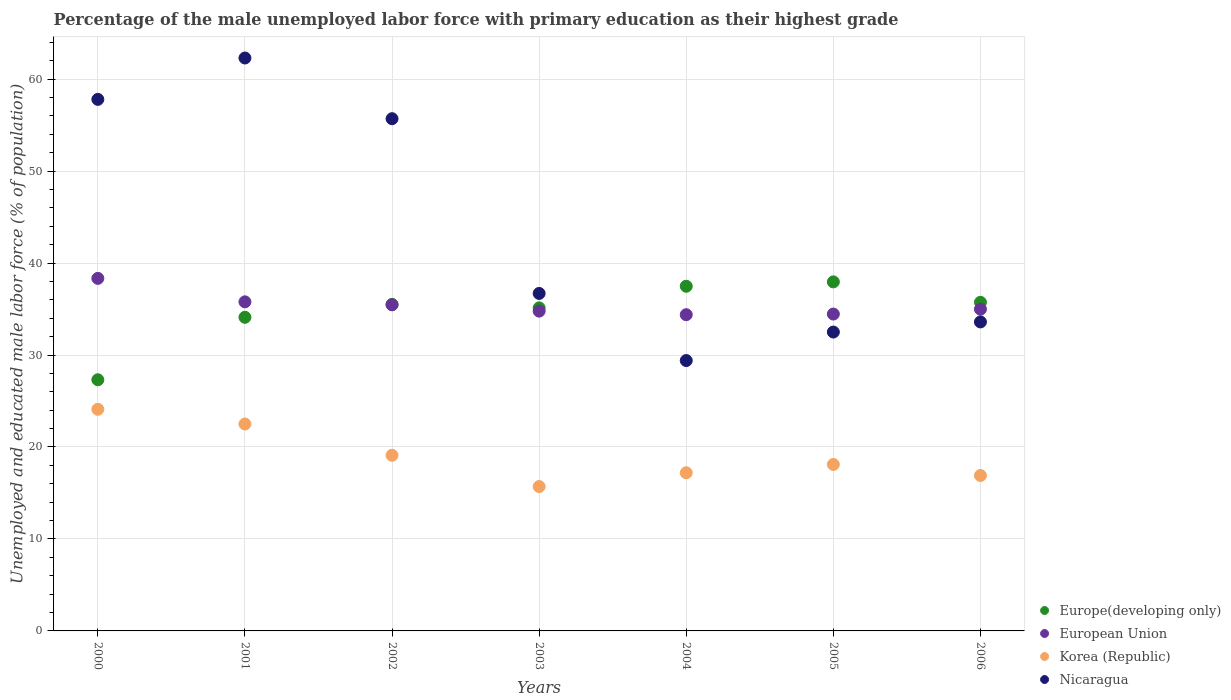How many different coloured dotlines are there?
Your answer should be very brief. 4. What is the percentage of the unemployed male labor force with primary education in Nicaragua in 2001?
Ensure brevity in your answer.  62.3. Across all years, what is the maximum percentage of the unemployed male labor force with primary education in European Union?
Give a very brief answer. 38.34. Across all years, what is the minimum percentage of the unemployed male labor force with primary education in Europe(developing only)?
Offer a very short reply. 27.31. In which year was the percentage of the unemployed male labor force with primary education in European Union maximum?
Ensure brevity in your answer.  2000. What is the total percentage of the unemployed male labor force with primary education in Nicaragua in the graph?
Provide a succinct answer. 308. What is the difference between the percentage of the unemployed male labor force with primary education in European Union in 2003 and that in 2006?
Keep it short and to the point. -0.21. What is the difference between the percentage of the unemployed male labor force with primary education in Nicaragua in 2002 and the percentage of the unemployed male labor force with primary education in Korea (Republic) in 2000?
Your answer should be very brief. 31.6. What is the average percentage of the unemployed male labor force with primary education in Europe(developing only) per year?
Offer a very short reply. 34.75. In the year 2006, what is the difference between the percentage of the unemployed male labor force with primary education in Korea (Republic) and percentage of the unemployed male labor force with primary education in European Union?
Give a very brief answer. -18.09. In how many years, is the percentage of the unemployed male labor force with primary education in Europe(developing only) greater than 36 %?
Keep it short and to the point. 2. What is the ratio of the percentage of the unemployed male labor force with primary education in Korea (Republic) in 2000 to that in 2002?
Your answer should be very brief. 1.26. Is the percentage of the unemployed male labor force with primary education in Nicaragua in 2000 less than that in 2005?
Give a very brief answer. No. Is the difference between the percentage of the unemployed male labor force with primary education in Korea (Republic) in 2001 and 2003 greater than the difference between the percentage of the unemployed male labor force with primary education in European Union in 2001 and 2003?
Your response must be concise. Yes. What is the difference between the highest and the second highest percentage of the unemployed male labor force with primary education in Korea (Republic)?
Provide a short and direct response. 1.6. What is the difference between the highest and the lowest percentage of the unemployed male labor force with primary education in Korea (Republic)?
Ensure brevity in your answer.  8.4. Is the sum of the percentage of the unemployed male labor force with primary education in European Union in 2002 and 2005 greater than the maximum percentage of the unemployed male labor force with primary education in Nicaragua across all years?
Make the answer very short. Yes. Is it the case that in every year, the sum of the percentage of the unemployed male labor force with primary education in Korea (Republic) and percentage of the unemployed male labor force with primary education in Europe(developing only)  is greater than the sum of percentage of the unemployed male labor force with primary education in Nicaragua and percentage of the unemployed male labor force with primary education in European Union?
Keep it short and to the point. No. How many dotlines are there?
Ensure brevity in your answer.  4. Are the values on the major ticks of Y-axis written in scientific E-notation?
Offer a terse response. No. Does the graph contain any zero values?
Make the answer very short. No. Where does the legend appear in the graph?
Your response must be concise. Bottom right. How are the legend labels stacked?
Provide a succinct answer. Vertical. What is the title of the graph?
Your answer should be compact. Percentage of the male unemployed labor force with primary education as their highest grade. Does "Euro area" appear as one of the legend labels in the graph?
Make the answer very short. No. What is the label or title of the X-axis?
Provide a succinct answer. Years. What is the label or title of the Y-axis?
Make the answer very short. Unemployed and educated male labor force (% of population). What is the Unemployed and educated male labor force (% of population) in Europe(developing only) in 2000?
Provide a succinct answer. 27.31. What is the Unemployed and educated male labor force (% of population) of European Union in 2000?
Your answer should be very brief. 38.34. What is the Unemployed and educated male labor force (% of population) in Korea (Republic) in 2000?
Your response must be concise. 24.1. What is the Unemployed and educated male labor force (% of population) of Nicaragua in 2000?
Give a very brief answer. 57.8. What is the Unemployed and educated male labor force (% of population) of Europe(developing only) in 2001?
Your response must be concise. 34.1. What is the Unemployed and educated male labor force (% of population) of European Union in 2001?
Offer a very short reply. 35.79. What is the Unemployed and educated male labor force (% of population) of Korea (Republic) in 2001?
Provide a succinct answer. 22.5. What is the Unemployed and educated male labor force (% of population) of Nicaragua in 2001?
Provide a succinct answer. 62.3. What is the Unemployed and educated male labor force (% of population) in Europe(developing only) in 2002?
Keep it short and to the point. 35.51. What is the Unemployed and educated male labor force (% of population) of European Union in 2002?
Make the answer very short. 35.46. What is the Unemployed and educated male labor force (% of population) in Korea (Republic) in 2002?
Provide a short and direct response. 19.1. What is the Unemployed and educated male labor force (% of population) in Nicaragua in 2002?
Keep it short and to the point. 55.7. What is the Unemployed and educated male labor force (% of population) in Europe(developing only) in 2003?
Make the answer very short. 35.13. What is the Unemployed and educated male labor force (% of population) in European Union in 2003?
Your response must be concise. 34.77. What is the Unemployed and educated male labor force (% of population) in Korea (Republic) in 2003?
Give a very brief answer. 15.7. What is the Unemployed and educated male labor force (% of population) in Nicaragua in 2003?
Give a very brief answer. 36.7. What is the Unemployed and educated male labor force (% of population) in Europe(developing only) in 2004?
Your answer should be compact. 37.48. What is the Unemployed and educated male labor force (% of population) of European Union in 2004?
Make the answer very short. 34.39. What is the Unemployed and educated male labor force (% of population) in Korea (Republic) in 2004?
Your response must be concise. 17.2. What is the Unemployed and educated male labor force (% of population) in Nicaragua in 2004?
Keep it short and to the point. 29.4. What is the Unemployed and educated male labor force (% of population) of Europe(developing only) in 2005?
Your response must be concise. 37.96. What is the Unemployed and educated male labor force (% of population) of European Union in 2005?
Your answer should be very brief. 34.46. What is the Unemployed and educated male labor force (% of population) in Korea (Republic) in 2005?
Your response must be concise. 18.1. What is the Unemployed and educated male labor force (% of population) of Nicaragua in 2005?
Offer a very short reply. 32.5. What is the Unemployed and educated male labor force (% of population) in Europe(developing only) in 2006?
Offer a terse response. 35.73. What is the Unemployed and educated male labor force (% of population) of European Union in 2006?
Ensure brevity in your answer.  34.99. What is the Unemployed and educated male labor force (% of population) of Korea (Republic) in 2006?
Provide a short and direct response. 16.9. What is the Unemployed and educated male labor force (% of population) of Nicaragua in 2006?
Make the answer very short. 33.6. Across all years, what is the maximum Unemployed and educated male labor force (% of population) in Europe(developing only)?
Offer a terse response. 37.96. Across all years, what is the maximum Unemployed and educated male labor force (% of population) in European Union?
Make the answer very short. 38.34. Across all years, what is the maximum Unemployed and educated male labor force (% of population) in Korea (Republic)?
Give a very brief answer. 24.1. Across all years, what is the maximum Unemployed and educated male labor force (% of population) of Nicaragua?
Your answer should be compact. 62.3. Across all years, what is the minimum Unemployed and educated male labor force (% of population) of Europe(developing only)?
Ensure brevity in your answer.  27.31. Across all years, what is the minimum Unemployed and educated male labor force (% of population) of European Union?
Keep it short and to the point. 34.39. Across all years, what is the minimum Unemployed and educated male labor force (% of population) of Korea (Republic)?
Ensure brevity in your answer.  15.7. Across all years, what is the minimum Unemployed and educated male labor force (% of population) in Nicaragua?
Make the answer very short. 29.4. What is the total Unemployed and educated male labor force (% of population) in Europe(developing only) in the graph?
Provide a succinct answer. 243.22. What is the total Unemployed and educated male labor force (% of population) of European Union in the graph?
Offer a very short reply. 248.19. What is the total Unemployed and educated male labor force (% of population) in Korea (Republic) in the graph?
Provide a short and direct response. 133.6. What is the total Unemployed and educated male labor force (% of population) of Nicaragua in the graph?
Offer a terse response. 308. What is the difference between the Unemployed and educated male labor force (% of population) in Europe(developing only) in 2000 and that in 2001?
Your answer should be very brief. -6.79. What is the difference between the Unemployed and educated male labor force (% of population) of European Union in 2000 and that in 2001?
Your answer should be compact. 2.55. What is the difference between the Unemployed and educated male labor force (% of population) in Europe(developing only) in 2000 and that in 2002?
Your response must be concise. -8.2. What is the difference between the Unemployed and educated male labor force (% of population) in European Union in 2000 and that in 2002?
Your answer should be compact. 2.88. What is the difference between the Unemployed and educated male labor force (% of population) of Nicaragua in 2000 and that in 2002?
Offer a very short reply. 2.1. What is the difference between the Unemployed and educated male labor force (% of population) of Europe(developing only) in 2000 and that in 2003?
Your response must be concise. -7.82. What is the difference between the Unemployed and educated male labor force (% of population) of European Union in 2000 and that in 2003?
Keep it short and to the point. 3.56. What is the difference between the Unemployed and educated male labor force (% of population) of Korea (Republic) in 2000 and that in 2003?
Your answer should be compact. 8.4. What is the difference between the Unemployed and educated male labor force (% of population) of Nicaragua in 2000 and that in 2003?
Your answer should be very brief. 21.1. What is the difference between the Unemployed and educated male labor force (% of population) of Europe(developing only) in 2000 and that in 2004?
Offer a very short reply. -10.17. What is the difference between the Unemployed and educated male labor force (% of population) in European Union in 2000 and that in 2004?
Offer a terse response. 3.95. What is the difference between the Unemployed and educated male labor force (% of population) of Korea (Republic) in 2000 and that in 2004?
Provide a succinct answer. 6.9. What is the difference between the Unemployed and educated male labor force (% of population) of Nicaragua in 2000 and that in 2004?
Your answer should be compact. 28.4. What is the difference between the Unemployed and educated male labor force (% of population) of Europe(developing only) in 2000 and that in 2005?
Your answer should be very brief. -10.64. What is the difference between the Unemployed and educated male labor force (% of population) of European Union in 2000 and that in 2005?
Ensure brevity in your answer.  3.88. What is the difference between the Unemployed and educated male labor force (% of population) of Nicaragua in 2000 and that in 2005?
Keep it short and to the point. 25.3. What is the difference between the Unemployed and educated male labor force (% of population) of Europe(developing only) in 2000 and that in 2006?
Your answer should be compact. -8.42. What is the difference between the Unemployed and educated male labor force (% of population) in European Union in 2000 and that in 2006?
Keep it short and to the point. 3.35. What is the difference between the Unemployed and educated male labor force (% of population) of Korea (Republic) in 2000 and that in 2006?
Give a very brief answer. 7.2. What is the difference between the Unemployed and educated male labor force (% of population) in Nicaragua in 2000 and that in 2006?
Your answer should be compact. 24.2. What is the difference between the Unemployed and educated male labor force (% of population) in Europe(developing only) in 2001 and that in 2002?
Provide a succinct answer. -1.41. What is the difference between the Unemployed and educated male labor force (% of population) of European Union in 2001 and that in 2002?
Keep it short and to the point. 0.32. What is the difference between the Unemployed and educated male labor force (% of population) of Europe(developing only) in 2001 and that in 2003?
Provide a short and direct response. -1.03. What is the difference between the Unemployed and educated male labor force (% of population) in European Union in 2001 and that in 2003?
Make the answer very short. 1.01. What is the difference between the Unemployed and educated male labor force (% of population) of Korea (Republic) in 2001 and that in 2003?
Your answer should be very brief. 6.8. What is the difference between the Unemployed and educated male labor force (% of population) in Nicaragua in 2001 and that in 2003?
Offer a terse response. 25.6. What is the difference between the Unemployed and educated male labor force (% of population) of Europe(developing only) in 2001 and that in 2004?
Offer a terse response. -3.38. What is the difference between the Unemployed and educated male labor force (% of population) in European Union in 2001 and that in 2004?
Your answer should be very brief. 1.4. What is the difference between the Unemployed and educated male labor force (% of population) in Nicaragua in 2001 and that in 2004?
Ensure brevity in your answer.  32.9. What is the difference between the Unemployed and educated male labor force (% of population) in Europe(developing only) in 2001 and that in 2005?
Ensure brevity in your answer.  -3.85. What is the difference between the Unemployed and educated male labor force (% of population) of European Union in 2001 and that in 2005?
Provide a succinct answer. 1.33. What is the difference between the Unemployed and educated male labor force (% of population) in Korea (Republic) in 2001 and that in 2005?
Your response must be concise. 4.4. What is the difference between the Unemployed and educated male labor force (% of population) in Nicaragua in 2001 and that in 2005?
Your response must be concise. 29.8. What is the difference between the Unemployed and educated male labor force (% of population) of Europe(developing only) in 2001 and that in 2006?
Make the answer very short. -1.63. What is the difference between the Unemployed and educated male labor force (% of population) of European Union in 2001 and that in 2006?
Your answer should be very brief. 0.8. What is the difference between the Unemployed and educated male labor force (% of population) of Korea (Republic) in 2001 and that in 2006?
Give a very brief answer. 5.6. What is the difference between the Unemployed and educated male labor force (% of population) of Nicaragua in 2001 and that in 2006?
Give a very brief answer. 28.7. What is the difference between the Unemployed and educated male labor force (% of population) of Europe(developing only) in 2002 and that in 2003?
Offer a very short reply. 0.38. What is the difference between the Unemployed and educated male labor force (% of population) in European Union in 2002 and that in 2003?
Ensure brevity in your answer.  0.69. What is the difference between the Unemployed and educated male labor force (% of population) in Korea (Republic) in 2002 and that in 2003?
Make the answer very short. 3.4. What is the difference between the Unemployed and educated male labor force (% of population) in Nicaragua in 2002 and that in 2003?
Make the answer very short. 19. What is the difference between the Unemployed and educated male labor force (% of population) in Europe(developing only) in 2002 and that in 2004?
Make the answer very short. -1.97. What is the difference between the Unemployed and educated male labor force (% of population) of European Union in 2002 and that in 2004?
Make the answer very short. 1.08. What is the difference between the Unemployed and educated male labor force (% of population) of Nicaragua in 2002 and that in 2004?
Ensure brevity in your answer.  26.3. What is the difference between the Unemployed and educated male labor force (% of population) of Europe(developing only) in 2002 and that in 2005?
Make the answer very short. -2.45. What is the difference between the Unemployed and educated male labor force (% of population) in European Union in 2002 and that in 2005?
Your answer should be compact. 1.01. What is the difference between the Unemployed and educated male labor force (% of population) of Nicaragua in 2002 and that in 2005?
Offer a terse response. 23.2. What is the difference between the Unemployed and educated male labor force (% of population) of Europe(developing only) in 2002 and that in 2006?
Ensure brevity in your answer.  -0.22. What is the difference between the Unemployed and educated male labor force (% of population) of European Union in 2002 and that in 2006?
Provide a succinct answer. 0.48. What is the difference between the Unemployed and educated male labor force (% of population) of Nicaragua in 2002 and that in 2006?
Offer a terse response. 22.1. What is the difference between the Unemployed and educated male labor force (% of population) of Europe(developing only) in 2003 and that in 2004?
Provide a short and direct response. -2.35. What is the difference between the Unemployed and educated male labor force (% of population) of European Union in 2003 and that in 2004?
Your answer should be compact. 0.39. What is the difference between the Unemployed and educated male labor force (% of population) in Europe(developing only) in 2003 and that in 2005?
Offer a terse response. -2.83. What is the difference between the Unemployed and educated male labor force (% of population) of European Union in 2003 and that in 2005?
Offer a terse response. 0.32. What is the difference between the Unemployed and educated male labor force (% of population) of Korea (Republic) in 2003 and that in 2005?
Provide a short and direct response. -2.4. What is the difference between the Unemployed and educated male labor force (% of population) of Europe(developing only) in 2003 and that in 2006?
Your response must be concise. -0.6. What is the difference between the Unemployed and educated male labor force (% of population) of European Union in 2003 and that in 2006?
Ensure brevity in your answer.  -0.21. What is the difference between the Unemployed and educated male labor force (% of population) in Korea (Republic) in 2003 and that in 2006?
Make the answer very short. -1.2. What is the difference between the Unemployed and educated male labor force (% of population) in Europe(developing only) in 2004 and that in 2005?
Offer a terse response. -0.47. What is the difference between the Unemployed and educated male labor force (% of population) in European Union in 2004 and that in 2005?
Your answer should be compact. -0.07. What is the difference between the Unemployed and educated male labor force (% of population) of Korea (Republic) in 2004 and that in 2005?
Give a very brief answer. -0.9. What is the difference between the Unemployed and educated male labor force (% of population) in Europe(developing only) in 2004 and that in 2006?
Offer a very short reply. 1.75. What is the difference between the Unemployed and educated male labor force (% of population) in European Union in 2004 and that in 2006?
Provide a succinct answer. -0.6. What is the difference between the Unemployed and educated male labor force (% of population) of Korea (Republic) in 2004 and that in 2006?
Your response must be concise. 0.3. What is the difference between the Unemployed and educated male labor force (% of population) of Nicaragua in 2004 and that in 2006?
Your response must be concise. -4.2. What is the difference between the Unemployed and educated male labor force (% of population) in Europe(developing only) in 2005 and that in 2006?
Keep it short and to the point. 2.22. What is the difference between the Unemployed and educated male labor force (% of population) of European Union in 2005 and that in 2006?
Make the answer very short. -0.53. What is the difference between the Unemployed and educated male labor force (% of population) of Europe(developing only) in 2000 and the Unemployed and educated male labor force (% of population) of European Union in 2001?
Your answer should be very brief. -8.48. What is the difference between the Unemployed and educated male labor force (% of population) in Europe(developing only) in 2000 and the Unemployed and educated male labor force (% of population) in Korea (Republic) in 2001?
Provide a succinct answer. 4.81. What is the difference between the Unemployed and educated male labor force (% of population) of Europe(developing only) in 2000 and the Unemployed and educated male labor force (% of population) of Nicaragua in 2001?
Offer a terse response. -34.99. What is the difference between the Unemployed and educated male labor force (% of population) in European Union in 2000 and the Unemployed and educated male labor force (% of population) in Korea (Republic) in 2001?
Make the answer very short. 15.84. What is the difference between the Unemployed and educated male labor force (% of population) in European Union in 2000 and the Unemployed and educated male labor force (% of population) in Nicaragua in 2001?
Give a very brief answer. -23.96. What is the difference between the Unemployed and educated male labor force (% of population) in Korea (Republic) in 2000 and the Unemployed and educated male labor force (% of population) in Nicaragua in 2001?
Provide a short and direct response. -38.2. What is the difference between the Unemployed and educated male labor force (% of population) of Europe(developing only) in 2000 and the Unemployed and educated male labor force (% of population) of European Union in 2002?
Offer a terse response. -8.15. What is the difference between the Unemployed and educated male labor force (% of population) in Europe(developing only) in 2000 and the Unemployed and educated male labor force (% of population) in Korea (Republic) in 2002?
Keep it short and to the point. 8.21. What is the difference between the Unemployed and educated male labor force (% of population) of Europe(developing only) in 2000 and the Unemployed and educated male labor force (% of population) of Nicaragua in 2002?
Keep it short and to the point. -28.39. What is the difference between the Unemployed and educated male labor force (% of population) of European Union in 2000 and the Unemployed and educated male labor force (% of population) of Korea (Republic) in 2002?
Make the answer very short. 19.24. What is the difference between the Unemployed and educated male labor force (% of population) of European Union in 2000 and the Unemployed and educated male labor force (% of population) of Nicaragua in 2002?
Your answer should be compact. -17.36. What is the difference between the Unemployed and educated male labor force (% of population) of Korea (Republic) in 2000 and the Unemployed and educated male labor force (% of population) of Nicaragua in 2002?
Make the answer very short. -31.6. What is the difference between the Unemployed and educated male labor force (% of population) of Europe(developing only) in 2000 and the Unemployed and educated male labor force (% of population) of European Union in 2003?
Your response must be concise. -7.46. What is the difference between the Unemployed and educated male labor force (% of population) in Europe(developing only) in 2000 and the Unemployed and educated male labor force (% of population) in Korea (Republic) in 2003?
Your answer should be very brief. 11.61. What is the difference between the Unemployed and educated male labor force (% of population) in Europe(developing only) in 2000 and the Unemployed and educated male labor force (% of population) in Nicaragua in 2003?
Provide a succinct answer. -9.39. What is the difference between the Unemployed and educated male labor force (% of population) in European Union in 2000 and the Unemployed and educated male labor force (% of population) in Korea (Republic) in 2003?
Offer a terse response. 22.64. What is the difference between the Unemployed and educated male labor force (% of population) in European Union in 2000 and the Unemployed and educated male labor force (% of population) in Nicaragua in 2003?
Your answer should be compact. 1.64. What is the difference between the Unemployed and educated male labor force (% of population) of Korea (Republic) in 2000 and the Unemployed and educated male labor force (% of population) of Nicaragua in 2003?
Offer a very short reply. -12.6. What is the difference between the Unemployed and educated male labor force (% of population) of Europe(developing only) in 2000 and the Unemployed and educated male labor force (% of population) of European Union in 2004?
Offer a terse response. -7.07. What is the difference between the Unemployed and educated male labor force (% of population) of Europe(developing only) in 2000 and the Unemployed and educated male labor force (% of population) of Korea (Republic) in 2004?
Make the answer very short. 10.11. What is the difference between the Unemployed and educated male labor force (% of population) of Europe(developing only) in 2000 and the Unemployed and educated male labor force (% of population) of Nicaragua in 2004?
Your answer should be very brief. -2.09. What is the difference between the Unemployed and educated male labor force (% of population) in European Union in 2000 and the Unemployed and educated male labor force (% of population) in Korea (Republic) in 2004?
Ensure brevity in your answer.  21.14. What is the difference between the Unemployed and educated male labor force (% of population) in European Union in 2000 and the Unemployed and educated male labor force (% of population) in Nicaragua in 2004?
Make the answer very short. 8.94. What is the difference between the Unemployed and educated male labor force (% of population) in Korea (Republic) in 2000 and the Unemployed and educated male labor force (% of population) in Nicaragua in 2004?
Provide a succinct answer. -5.3. What is the difference between the Unemployed and educated male labor force (% of population) in Europe(developing only) in 2000 and the Unemployed and educated male labor force (% of population) in European Union in 2005?
Your answer should be compact. -7.15. What is the difference between the Unemployed and educated male labor force (% of population) in Europe(developing only) in 2000 and the Unemployed and educated male labor force (% of population) in Korea (Republic) in 2005?
Offer a very short reply. 9.21. What is the difference between the Unemployed and educated male labor force (% of population) of Europe(developing only) in 2000 and the Unemployed and educated male labor force (% of population) of Nicaragua in 2005?
Give a very brief answer. -5.19. What is the difference between the Unemployed and educated male labor force (% of population) in European Union in 2000 and the Unemployed and educated male labor force (% of population) in Korea (Republic) in 2005?
Your answer should be compact. 20.24. What is the difference between the Unemployed and educated male labor force (% of population) in European Union in 2000 and the Unemployed and educated male labor force (% of population) in Nicaragua in 2005?
Your answer should be very brief. 5.84. What is the difference between the Unemployed and educated male labor force (% of population) of Korea (Republic) in 2000 and the Unemployed and educated male labor force (% of population) of Nicaragua in 2005?
Make the answer very short. -8.4. What is the difference between the Unemployed and educated male labor force (% of population) in Europe(developing only) in 2000 and the Unemployed and educated male labor force (% of population) in European Union in 2006?
Keep it short and to the point. -7.68. What is the difference between the Unemployed and educated male labor force (% of population) in Europe(developing only) in 2000 and the Unemployed and educated male labor force (% of population) in Korea (Republic) in 2006?
Your answer should be compact. 10.41. What is the difference between the Unemployed and educated male labor force (% of population) of Europe(developing only) in 2000 and the Unemployed and educated male labor force (% of population) of Nicaragua in 2006?
Your response must be concise. -6.29. What is the difference between the Unemployed and educated male labor force (% of population) in European Union in 2000 and the Unemployed and educated male labor force (% of population) in Korea (Republic) in 2006?
Give a very brief answer. 21.44. What is the difference between the Unemployed and educated male labor force (% of population) of European Union in 2000 and the Unemployed and educated male labor force (% of population) of Nicaragua in 2006?
Make the answer very short. 4.74. What is the difference between the Unemployed and educated male labor force (% of population) in Europe(developing only) in 2001 and the Unemployed and educated male labor force (% of population) in European Union in 2002?
Give a very brief answer. -1.36. What is the difference between the Unemployed and educated male labor force (% of population) in Europe(developing only) in 2001 and the Unemployed and educated male labor force (% of population) in Korea (Republic) in 2002?
Offer a very short reply. 15. What is the difference between the Unemployed and educated male labor force (% of population) in Europe(developing only) in 2001 and the Unemployed and educated male labor force (% of population) in Nicaragua in 2002?
Provide a short and direct response. -21.6. What is the difference between the Unemployed and educated male labor force (% of population) of European Union in 2001 and the Unemployed and educated male labor force (% of population) of Korea (Republic) in 2002?
Your response must be concise. 16.69. What is the difference between the Unemployed and educated male labor force (% of population) of European Union in 2001 and the Unemployed and educated male labor force (% of population) of Nicaragua in 2002?
Provide a succinct answer. -19.91. What is the difference between the Unemployed and educated male labor force (% of population) of Korea (Republic) in 2001 and the Unemployed and educated male labor force (% of population) of Nicaragua in 2002?
Ensure brevity in your answer.  -33.2. What is the difference between the Unemployed and educated male labor force (% of population) of Europe(developing only) in 2001 and the Unemployed and educated male labor force (% of population) of European Union in 2003?
Your answer should be very brief. -0.67. What is the difference between the Unemployed and educated male labor force (% of population) in Europe(developing only) in 2001 and the Unemployed and educated male labor force (% of population) in Korea (Republic) in 2003?
Provide a short and direct response. 18.4. What is the difference between the Unemployed and educated male labor force (% of population) in Europe(developing only) in 2001 and the Unemployed and educated male labor force (% of population) in Nicaragua in 2003?
Keep it short and to the point. -2.6. What is the difference between the Unemployed and educated male labor force (% of population) of European Union in 2001 and the Unemployed and educated male labor force (% of population) of Korea (Republic) in 2003?
Give a very brief answer. 20.09. What is the difference between the Unemployed and educated male labor force (% of population) of European Union in 2001 and the Unemployed and educated male labor force (% of population) of Nicaragua in 2003?
Your answer should be very brief. -0.91. What is the difference between the Unemployed and educated male labor force (% of population) in Korea (Republic) in 2001 and the Unemployed and educated male labor force (% of population) in Nicaragua in 2003?
Your response must be concise. -14.2. What is the difference between the Unemployed and educated male labor force (% of population) in Europe(developing only) in 2001 and the Unemployed and educated male labor force (% of population) in European Union in 2004?
Your response must be concise. -0.28. What is the difference between the Unemployed and educated male labor force (% of population) in Europe(developing only) in 2001 and the Unemployed and educated male labor force (% of population) in Korea (Republic) in 2004?
Provide a succinct answer. 16.9. What is the difference between the Unemployed and educated male labor force (% of population) in Europe(developing only) in 2001 and the Unemployed and educated male labor force (% of population) in Nicaragua in 2004?
Make the answer very short. 4.7. What is the difference between the Unemployed and educated male labor force (% of population) of European Union in 2001 and the Unemployed and educated male labor force (% of population) of Korea (Republic) in 2004?
Keep it short and to the point. 18.59. What is the difference between the Unemployed and educated male labor force (% of population) in European Union in 2001 and the Unemployed and educated male labor force (% of population) in Nicaragua in 2004?
Your response must be concise. 6.39. What is the difference between the Unemployed and educated male labor force (% of population) in Korea (Republic) in 2001 and the Unemployed and educated male labor force (% of population) in Nicaragua in 2004?
Keep it short and to the point. -6.9. What is the difference between the Unemployed and educated male labor force (% of population) in Europe(developing only) in 2001 and the Unemployed and educated male labor force (% of population) in European Union in 2005?
Ensure brevity in your answer.  -0.35. What is the difference between the Unemployed and educated male labor force (% of population) of Europe(developing only) in 2001 and the Unemployed and educated male labor force (% of population) of Korea (Republic) in 2005?
Offer a terse response. 16. What is the difference between the Unemployed and educated male labor force (% of population) of Europe(developing only) in 2001 and the Unemployed and educated male labor force (% of population) of Nicaragua in 2005?
Provide a short and direct response. 1.6. What is the difference between the Unemployed and educated male labor force (% of population) of European Union in 2001 and the Unemployed and educated male labor force (% of population) of Korea (Republic) in 2005?
Keep it short and to the point. 17.69. What is the difference between the Unemployed and educated male labor force (% of population) of European Union in 2001 and the Unemployed and educated male labor force (% of population) of Nicaragua in 2005?
Your response must be concise. 3.29. What is the difference between the Unemployed and educated male labor force (% of population) in Korea (Republic) in 2001 and the Unemployed and educated male labor force (% of population) in Nicaragua in 2005?
Provide a short and direct response. -10. What is the difference between the Unemployed and educated male labor force (% of population) in Europe(developing only) in 2001 and the Unemployed and educated male labor force (% of population) in European Union in 2006?
Offer a very short reply. -0.88. What is the difference between the Unemployed and educated male labor force (% of population) of Europe(developing only) in 2001 and the Unemployed and educated male labor force (% of population) of Korea (Republic) in 2006?
Your answer should be compact. 17.2. What is the difference between the Unemployed and educated male labor force (% of population) of Europe(developing only) in 2001 and the Unemployed and educated male labor force (% of population) of Nicaragua in 2006?
Make the answer very short. 0.5. What is the difference between the Unemployed and educated male labor force (% of population) in European Union in 2001 and the Unemployed and educated male labor force (% of population) in Korea (Republic) in 2006?
Offer a very short reply. 18.89. What is the difference between the Unemployed and educated male labor force (% of population) in European Union in 2001 and the Unemployed and educated male labor force (% of population) in Nicaragua in 2006?
Provide a succinct answer. 2.19. What is the difference between the Unemployed and educated male labor force (% of population) in Europe(developing only) in 2002 and the Unemployed and educated male labor force (% of population) in European Union in 2003?
Offer a terse response. 0.73. What is the difference between the Unemployed and educated male labor force (% of population) in Europe(developing only) in 2002 and the Unemployed and educated male labor force (% of population) in Korea (Republic) in 2003?
Provide a short and direct response. 19.81. What is the difference between the Unemployed and educated male labor force (% of population) in Europe(developing only) in 2002 and the Unemployed and educated male labor force (% of population) in Nicaragua in 2003?
Offer a very short reply. -1.19. What is the difference between the Unemployed and educated male labor force (% of population) in European Union in 2002 and the Unemployed and educated male labor force (% of population) in Korea (Republic) in 2003?
Offer a very short reply. 19.76. What is the difference between the Unemployed and educated male labor force (% of population) in European Union in 2002 and the Unemployed and educated male labor force (% of population) in Nicaragua in 2003?
Provide a succinct answer. -1.24. What is the difference between the Unemployed and educated male labor force (% of population) of Korea (Republic) in 2002 and the Unemployed and educated male labor force (% of population) of Nicaragua in 2003?
Provide a succinct answer. -17.6. What is the difference between the Unemployed and educated male labor force (% of population) of Europe(developing only) in 2002 and the Unemployed and educated male labor force (% of population) of European Union in 2004?
Make the answer very short. 1.12. What is the difference between the Unemployed and educated male labor force (% of population) in Europe(developing only) in 2002 and the Unemployed and educated male labor force (% of population) in Korea (Republic) in 2004?
Offer a terse response. 18.31. What is the difference between the Unemployed and educated male labor force (% of population) in Europe(developing only) in 2002 and the Unemployed and educated male labor force (% of population) in Nicaragua in 2004?
Keep it short and to the point. 6.11. What is the difference between the Unemployed and educated male labor force (% of population) in European Union in 2002 and the Unemployed and educated male labor force (% of population) in Korea (Republic) in 2004?
Keep it short and to the point. 18.26. What is the difference between the Unemployed and educated male labor force (% of population) in European Union in 2002 and the Unemployed and educated male labor force (% of population) in Nicaragua in 2004?
Provide a short and direct response. 6.06. What is the difference between the Unemployed and educated male labor force (% of population) of Korea (Republic) in 2002 and the Unemployed and educated male labor force (% of population) of Nicaragua in 2004?
Give a very brief answer. -10.3. What is the difference between the Unemployed and educated male labor force (% of population) of Europe(developing only) in 2002 and the Unemployed and educated male labor force (% of population) of European Union in 2005?
Offer a very short reply. 1.05. What is the difference between the Unemployed and educated male labor force (% of population) in Europe(developing only) in 2002 and the Unemployed and educated male labor force (% of population) in Korea (Republic) in 2005?
Give a very brief answer. 17.41. What is the difference between the Unemployed and educated male labor force (% of population) in Europe(developing only) in 2002 and the Unemployed and educated male labor force (% of population) in Nicaragua in 2005?
Your answer should be very brief. 3.01. What is the difference between the Unemployed and educated male labor force (% of population) of European Union in 2002 and the Unemployed and educated male labor force (% of population) of Korea (Republic) in 2005?
Provide a short and direct response. 17.36. What is the difference between the Unemployed and educated male labor force (% of population) of European Union in 2002 and the Unemployed and educated male labor force (% of population) of Nicaragua in 2005?
Ensure brevity in your answer.  2.96. What is the difference between the Unemployed and educated male labor force (% of population) in Korea (Republic) in 2002 and the Unemployed and educated male labor force (% of population) in Nicaragua in 2005?
Ensure brevity in your answer.  -13.4. What is the difference between the Unemployed and educated male labor force (% of population) in Europe(developing only) in 2002 and the Unemployed and educated male labor force (% of population) in European Union in 2006?
Your answer should be compact. 0.52. What is the difference between the Unemployed and educated male labor force (% of population) of Europe(developing only) in 2002 and the Unemployed and educated male labor force (% of population) of Korea (Republic) in 2006?
Your answer should be compact. 18.61. What is the difference between the Unemployed and educated male labor force (% of population) in Europe(developing only) in 2002 and the Unemployed and educated male labor force (% of population) in Nicaragua in 2006?
Your answer should be very brief. 1.91. What is the difference between the Unemployed and educated male labor force (% of population) of European Union in 2002 and the Unemployed and educated male labor force (% of population) of Korea (Republic) in 2006?
Provide a succinct answer. 18.56. What is the difference between the Unemployed and educated male labor force (% of population) in European Union in 2002 and the Unemployed and educated male labor force (% of population) in Nicaragua in 2006?
Offer a very short reply. 1.86. What is the difference between the Unemployed and educated male labor force (% of population) in Europe(developing only) in 2003 and the Unemployed and educated male labor force (% of population) in European Union in 2004?
Provide a succinct answer. 0.74. What is the difference between the Unemployed and educated male labor force (% of population) in Europe(developing only) in 2003 and the Unemployed and educated male labor force (% of population) in Korea (Republic) in 2004?
Ensure brevity in your answer.  17.93. What is the difference between the Unemployed and educated male labor force (% of population) in Europe(developing only) in 2003 and the Unemployed and educated male labor force (% of population) in Nicaragua in 2004?
Your response must be concise. 5.73. What is the difference between the Unemployed and educated male labor force (% of population) in European Union in 2003 and the Unemployed and educated male labor force (% of population) in Korea (Republic) in 2004?
Keep it short and to the point. 17.57. What is the difference between the Unemployed and educated male labor force (% of population) in European Union in 2003 and the Unemployed and educated male labor force (% of population) in Nicaragua in 2004?
Your answer should be very brief. 5.37. What is the difference between the Unemployed and educated male labor force (% of population) of Korea (Republic) in 2003 and the Unemployed and educated male labor force (% of population) of Nicaragua in 2004?
Your response must be concise. -13.7. What is the difference between the Unemployed and educated male labor force (% of population) in Europe(developing only) in 2003 and the Unemployed and educated male labor force (% of population) in European Union in 2005?
Your answer should be very brief. 0.67. What is the difference between the Unemployed and educated male labor force (% of population) in Europe(developing only) in 2003 and the Unemployed and educated male labor force (% of population) in Korea (Republic) in 2005?
Keep it short and to the point. 17.03. What is the difference between the Unemployed and educated male labor force (% of population) of Europe(developing only) in 2003 and the Unemployed and educated male labor force (% of population) of Nicaragua in 2005?
Offer a terse response. 2.63. What is the difference between the Unemployed and educated male labor force (% of population) of European Union in 2003 and the Unemployed and educated male labor force (% of population) of Korea (Republic) in 2005?
Offer a very short reply. 16.67. What is the difference between the Unemployed and educated male labor force (% of population) of European Union in 2003 and the Unemployed and educated male labor force (% of population) of Nicaragua in 2005?
Offer a terse response. 2.27. What is the difference between the Unemployed and educated male labor force (% of population) of Korea (Republic) in 2003 and the Unemployed and educated male labor force (% of population) of Nicaragua in 2005?
Ensure brevity in your answer.  -16.8. What is the difference between the Unemployed and educated male labor force (% of population) of Europe(developing only) in 2003 and the Unemployed and educated male labor force (% of population) of European Union in 2006?
Make the answer very short. 0.14. What is the difference between the Unemployed and educated male labor force (% of population) in Europe(developing only) in 2003 and the Unemployed and educated male labor force (% of population) in Korea (Republic) in 2006?
Your response must be concise. 18.23. What is the difference between the Unemployed and educated male labor force (% of population) in Europe(developing only) in 2003 and the Unemployed and educated male labor force (% of population) in Nicaragua in 2006?
Offer a very short reply. 1.53. What is the difference between the Unemployed and educated male labor force (% of population) in European Union in 2003 and the Unemployed and educated male labor force (% of population) in Korea (Republic) in 2006?
Give a very brief answer. 17.87. What is the difference between the Unemployed and educated male labor force (% of population) in European Union in 2003 and the Unemployed and educated male labor force (% of population) in Nicaragua in 2006?
Give a very brief answer. 1.17. What is the difference between the Unemployed and educated male labor force (% of population) of Korea (Republic) in 2003 and the Unemployed and educated male labor force (% of population) of Nicaragua in 2006?
Provide a succinct answer. -17.9. What is the difference between the Unemployed and educated male labor force (% of population) in Europe(developing only) in 2004 and the Unemployed and educated male labor force (% of population) in European Union in 2005?
Keep it short and to the point. 3.02. What is the difference between the Unemployed and educated male labor force (% of population) in Europe(developing only) in 2004 and the Unemployed and educated male labor force (% of population) in Korea (Republic) in 2005?
Offer a terse response. 19.38. What is the difference between the Unemployed and educated male labor force (% of population) in Europe(developing only) in 2004 and the Unemployed and educated male labor force (% of population) in Nicaragua in 2005?
Keep it short and to the point. 4.98. What is the difference between the Unemployed and educated male labor force (% of population) in European Union in 2004 and the Unemployed and educated male labor force (% of population) in Korea (Republic) in 2005?
Give a very brief answer. 16.29. What is the difference between the Unemployed and educated male labor force (% of population) in European Union in 2004 and the Unemployed and educated male labor force (% of population) in Nicaragua in 2005?
Keep it short and to the point. 1.89. What is the difference between the Unemployed and educated male labor force (% of population) of Korea (Republic) in 2004 and the Unemployed and educated male labor force (% of population) of Nicaragua in 2005?
Your answer should be very brief. -15.3. What is the difference between the Unemployed and educated male labor force (% of population) in Europe(developing only) in 2004 and the Unemployed and educated male labor force (% of population) in European Union in 2006?
Offer a terse response. 2.49. What is the difference between the Unemployed and educated male labor force (% of population) in Europe(developing only) in 2004 and the Unemployed and educated male labor force (% of population) in Korea (Republic) in 2006?
Your answer should be very brief. 20.58. What is the difference between the Unemployed and educated male labor force (% of population) of Europe(developing only) in 2004 and the Unemployed and educated male labor force (% of population) of Nicaragua in 2006?
Provide a short and direct response. 3.88. What is the difference between the Unemployed and educated male labor force (% of population) of European Union in 2004 and the Unemployed and educated male labor force (% of population) of Korea (Republic) in 2006?
Keep it short and to the point. 17.49. What is the difference between the Unemployed and educated male labor force (% of population) of European Union in 2004 and the Unemployed and educated male labor force (% of population) of Nicaragua in 2006?
Give a very brief answer. 0.79. What is the difference between the Unemployed and educated male labor force (% of population) in Korea (Republic) in 2004 and the Unemployed and educated male labor force (% of population) in Nicaragua in 2006?
Ensure brevity in your answer.  -16.4. What is the difference between the Unemployed and educated male labor force (% of population) of Europe(developing only) in 2005 and the Unemployed and educated male labor force (% of population) of European Union in 2006?
Your answer should be compact. 2.97. What is the difference between the Unemployed and educated male labor force (% of population) in Europe(developing only) in 2005 and the Unemployed and educated male labor force (% of population) in Korea (Republic) in 2006?
Your answer should be compact. 21.06. What is the difference between the Unemployed and educated male labor force (% of population) in Europe(developing only) in 2005 and the Unemployed and educated male labor force (% of population) in Nicaragua in 2006?
Give a very brief answer. 4.36. What is the difference between the Unemployed and educated male labor force (% of population) of European Union in 2005 and the Unemployed and educated male labor force (% of population) of Korea (Republic) in 2006?
Provide a succinct answer. 17.56. What is the difference between the Unemployed and educated male labor force (% of population) in European Union in 2005 and the Unemployed and educated male labor force (% of population) in Nicaragua in 2006?
Give a very brief answer. 0.86. What is the difference between the Unemployed and educated male labor force (% of population) in Korea (Republic) in 2005 and the Unemployed and educated male labor force (% of population) in Nicaragua in 2006?
Your response must be concise. -15.5. What is the average Unemployed and educated male labor force (% of population) of Europe(developing only) per year?
Give a very brief answer. 34.75. What is the average Unemployed and educated male labor force (% of population) of European Union per year?
Provide a succinct answer. 35.46. What is the average Unemployed and educated male labor force (% of population) in Korea (Republic) per year?
Offer a very short reply. 19.09. In the year 2000, what is the difference between the Unemployed and educated male labor force (% of population) of Europe(developing only) and Unemployed and educated male labor force (% of population) of European Union?
Your answer should be compact. -11.03. In the year 2000, what is the difference between the Unemployed and educated male labor force (% of population) in Europe(developing only) and Unemployed and educated male labor force (% of population) in Korea (Republic)?
Your response must be concise. 3.21. In the year 2000, what is the difference between the Unemployed and educated male labor force (% of population) in Europe(developing only) and Unemployed and educated male labor force (% of population) in Nicaragua?
Your answer should be very brief. -30.49. In the year 2000, what is the difference between the Unemployed and educated male labor force (% of population) of European Union and Unemployed and educated male labor force (% of population) of Korea (Republic)?
Keep it short and to the point. 14.24. In the year 2000, what is the difference between the Unemployed and educated male labor force (% of population) of European Union and Unemployed and educated male labor force (% of population) of Nicaragua?
Offer a very short reply. -19.46. In the year 2000, what is the difference between the Unemployed and educated male labor force (% of population) in Korea (Republic) and Unemployed and educated male labor force (% of population) in Nicaragua?
Offer a terse response. -33.7. In the year 2001, what is the difference between the Unemployed and educated male labor force (% of population) of Europe(developing only) and Unemployed and educated male labor force (% of population) of European Union?
Your answer should be very brief. -1.68. In the year 2001, what is the difference between the Unemployed and educated male labor force (% of population) in Europe(developing only) and Unemployed and educated male labor force (% of population) in Korea (Republic)?
Offer a very short reply. 11.6. In the year 2001, what is the difference between the Unemployed and educated male labor force (% of population) of Europe(developing only) and Unemployed and educated male labor force (% of population) of Nicaragua?
Offer a terse response. -28.2. In the year 2001, what is the difference between the Unemployed and educated male labor force (% of population) of European Union and Unemployed and educated male labor force (% of population) of Korea (Republic)?
Provide a short and direct response. 13.29. In the year 2001, what is the difference between the Unemployed and educated male labor force (% of population) of European Union and Unemployed and educated male labor force (% of population) of Nicaragua?
Keep it short and to the point. -26.51. In the year 2001, what is the difference between the Unemployed and educated male labor force (% of population) in Korea (Republic) and Unemployed and educated male labor force (% of population) in Nicaragua?
Keep it short and to the point. -39.8. In the year 2002, what is the difference between the Unemployed and educated male labor force (% of population) in Europe(developing only) and Unemployed and educated male labor force (% of population) in European Union?
Your answer should be very brief. 0.05. In the year 2002, what is the difference between the Unemployed and educated male labor force (% of population) of Europe(developing only) and Unemployed and educated male labor force (% of population) of Korea (Republic)?
Keep it short and to the point. 16.41. In the year 2002, what is the difference between the Unemployed and educated male labor force (% of population) of Europe(developing only) and Unemployed and educated male labor force (% of population) of Nicaragua?
Offer a very short reply. -20.19. In the year 2002, what is the difference between the Unemployed and educated male labor force (% of population) of European Union and Unemployed and educated male labor force (% of population) of Korea (Republic)?
Provide a succinct answer. 16.36. In the year 2002, what is the difference between the Unemployed and educated male labor force (% of population) of European Union and Unemployed and educated male labor force (% of population) of Nicaragua?
Give a very brief answer. -20.24. In the year 2002, what is the difference between the Unemployed and educated male labor force (% of population) of Korea (Republic) and Unemployed and educated male labor force (% of population) of Nicaragua?
Offer a very short reply. -36.6. In the year 2003, what is the difference between the Unemployed and educated male labor force (% of population) in Europe(developing only) and Unemployed and educated male labor force (% of population) in European Union?
Provide a short and direct response. 0.36. In the year 2003, what is the difference between the Unemployed and educated male labor force (% of population) of Europe(developing only) and Unemployed and educated male labor force (% of population) of Korea (Republic)?
Offer a terse response. 19.43. In the year 2003, what is the difference between the Unemployed and educated male labor force (% of population) in Europe(developing only) and Unemployed and educated male labor force (% of population) in Nicaragua?
Offer a very short reply. -1.57. In the year 2003, what is the difference between the Unemployed and educated male labor force (% of population) in European Union and Unemployed and educated male labor force (% of population) in Korea (Republic)?
Offer a terse response. 19.07. In the year 2003, what is the difference between the Unemployed and educated male labor force (% of population) of European Union and Unemployed and educated male labor force (% of population) of Nicaragua?
Give a very brief answer. -1.93. In the year 2004, what is the difference between the Unemployed and educated male labor force (% of population) of Europe(developing only) and Unemployed and educated male labor force (% of population) of European Union?
Your answer should be very brief. 3.1. In the year 2004, what is the difference between the Unemployed and educated male labor force (% of population) of Europe(developing only) and Unemployed and educated male labor force (% of population) of Korea (Republic)?
Offer a terse response. 20.28. In the year 2004, what is the difference between the Unemployed and educated male labor force (% of population) in Europe(developing only) and Unemployed and educated male labor force (% of population) in Nicaragua?
Offer a very short reply. 8.08. In the year 2004, what is the difference between the Unemployed and educated male labor force (% of population) of European Union and Unemployed and educated male labor force (% of population) of Korea (Republic)?
Offer a terse response. 17.19. In the year 2004, what is the difference between the Unemployed and educated male labor force (% of population) of European Union and Unemployed and educated male labor force (% of population) of Nicaragua?
Offer a terse response. 4.99. In the year 2005, what is the difference between the Unemployed and educated male labor force (% of population) in Europe(developing only) and Unemployed and educated male labor force (% of population) in European Union?
Your response must be concise. 3.5. In the year 2005, what is the difference between the Unemployed and educated male labor force (% of population) of Europe(developing only) and Unemployed and educated male labor force (% of population) of Korea (Republic)?
Provide a short and direct response. 19.86. In the year 2005, what is the difference between the Unemployed and educated male labor force (% of population) of Europe(developing only) and Unemployed and educated male labor force (% of population) of Nicaragua?
Your response must be concise. 5.46. In the year 2005, what is the difference between the Unemployed and educated male labor force (% of population) in European Union and Unemployed and educated male labor force (% of population) in Korea (Republic)?
Provide a succinct answer. 16.36. In the year 2005, what is the difference between the Unemployed and educated male labor force (% of population) of European Union and Unemployed and educated male labor force (% of population) of Nicaragua?
Provide a short and direct response. 1.96. In the year 2005, what is the difference between the Unemployed and educated male labor force (% of population) of Korea (Republic) and Unemployed and educated male labor force (% of population) of Nicaragua?
Your response must be concise. -14.4. In the year 2006, what is the difference between the Unemployed and educated male labor force (% of population) in Europe(developing only) and Unemployed and educated male labor force (% of population) in European Union?
Your answer should be very brief. 0.75. In the year 2006, what is the difference between the Unemployed and educated male labor force (% of population) of Europe(developing only) and Unemployed and educated male labor force (% of population) of Korea (Republic)?
Your response must be concise. 18.83. In the year 2006, what is the difference between the Unemployed and educated male labor force (% of population) of Europe(developing only) and Unemployed and educated male labor force (% of population) of Nicaragua?
Offer a terse response. 2.13. In the year 2006, what is the difference between the Unemployed and educated male labor force (% of population) of European Union and Unemployed and educated male labor force (% of population) of Korea (Republic)?
Ensure brevity in your answer.  18.09. In the year 2006, what is the difference between the Unemployed and educated male labor force (% of population) of European Union and Unemployed and educated male labor force (% of population) of Nicaragua?
Offer a terse response. 1.39. In the year 2006, what is the difference between the Unemployed and educated male labor force (% of population) of Korea (Republic) and Unemployed and educated male labor force (% of population) of Nicaragua?
Keep it short and to the point. -16.7. What is the ratio of the Unemployed and educated male labor force (% of population) of Europe(developing only) in 2000 to that in 2001?
Provide a succinct answer. 0.8. What is the ratio of the Unemployed and educated male labor force (% of population) in European Union in 2000 to that in 2001?
Your answer should be compact. 1.07. What is the ratio of the Unemployed and educated male labor force (% of population) in Korea (Republic) in 2000 to that in 2001?
Ensure brevity in your answer.  1.07. What is the ratio of the Unemployed and educated male labor force (% of population) in Nicaragua in 2000 to that in 2001?
Your answer should be compact. 0.93. What is the ratio of the Unemployed and educated male labor force (% of population) in Europe(developing only) in 2000 to that in 2002?
Ensure brevity in your answer.  0.77. What is the ratio of the Unemployed and educated male labor force (% of population) of European Union in 2000 to that in 2002?
Make the answer very short. 1.08. What is the ratio of the Unemployed and educated male labor force (% of population) of Korea (Republic) in 2000 to that in 2002?
Offer a very short reply. 1.26. What is the ratio of the Unemployed and educated male labor force (% of population) of Nicaragua in 2000 to that in 2002?
Your response must be concise. 1.04. What is the ratio of the Unemployed and educated male labor force (% of population) of Europe(developing only) in 2000 to that in 2003?
Your answer should be very brief. 0.78. What is the ratio of the Unemployed and educated male labor force (% of population) in European Union in 2000 to that in 2003?
Make the answer very short. 1.1. What is the ratio of the Unemployed and educated male labor force (% of population) of Korea (Republic) in 2000 to that in 2003?
Provide a succinct answer. 1.53. What is the ratio of the Unemployed and educated male labor force (% of population) of Nicaragua in 2000 to that in 2003?
Provide a short and direct response. 1.57. What is the ratio of the Unemployed and educated male labor force (% of population) of Europe(developing only) in 2000 to that in 2004?
Your answer should be very brief. 0.73. What is the ratio of the Unemployed and educated male labor force (% of population) in European Union in 2000 to that in 2004?
Ensure brevity in your answer.  1.11. What is the ratio of the Unemployed and educated male labor force (% of population) in Korea (Republic) in 2000 to that in 2004?
Offer a very short reply. 1.4. What is the ratio of the Unemployed and educated male labor force (% of population) in Nicaragua in 2000 to that in 2004?
Your answer should be very brief. 1.97. What is the ratio of the Unemployed and educated male labor force (% of population) of Europe(developing only) in 2000 to that in 2005?
Offer a terse response. 0.72. What is the ratio of the Unemployed and educated male labor force (% of population) of European Union in 2000 to that in 2005?
Offer a very short reply. 1.11. What is the ratio of the Unemployed and educated male labor force (% of population) in Korea (Republic) in 2000 to that in 2005?
Offer a very short reply. 1.33. What is the ratio of the Unemployed and educated male labor force (% of population) of Nicaragua in 2000 to that in 2005?
Offer a terse response. 1.78. What is the ratio of the Unemployed and educated male labor force (% of population) in Europe(developing only) in 2000 to that in 2006?
Keep it short and to the point. 0.76. What is the ratio of the Unemployed and educated male labor force (% of population) in European Union in 2000 to that in 2006?
Offer a very short reply. 1.1. What is the ratio of the Unemployed and educated male labor force (% of population) of Korea (Republic) in 2000 to that in 2006?
Ensure brevity in your answer.  1.43. What is the ratio of the Unemployed and educated male labor force (% of population) in Nicaragua in 2000 to that in 2006?
Make the answer very short. 1.72. What is the ratio of the Unemployed and educated male labor force (% of population) of Europe(developing only) in 2001 to that in 2002?
Make the answer very short. 0.96. What is the ratio of the Unemployed and educated male labor force (% of population) of European Union in 2001 to that in 2002?
Offer a terse response. 1.01. What is the ratio of the Unemployed and educated male labor force (% of population) in Korea (Republic) in 2001 to that in 2002?
Your answer should be compact. 1.18. What is the ratio of the Unemployed and educated male labor force (% of population) in Nicaragua in 2001 to that in 2002?
Provide a succinct answer. 1.12. What is the ratio of the Unemployed and educated male labor force (% of population) of Europe(developing only) in 2001 to that in 2003?
Keep it short and to the point. 0.97. What is the ratio of the Unemployed and educated male labor force (% of population) of European Union in 2001 to that in 2003?
Offer a terse response. 1.03. What is the ratio of the Unemployed and educated male labor force (% of population) in Korea (Republic) in 2001 to that in 2003?
Provide a succinct answer. 1.43. What is the ratio of the Unemployed and educated male labor force (% of population) of Nicaragua in 2001 to that in 2003?
Your answer should be very brief. 1.7. What is the ratio of the Unemployed and educated male labor force (% of population) in Europe(developing only) in 2001 to that in 2004?
Provide a succinct answer. 0.91. What is the ratio of the Unemployed and educated male labor force (% of population) in European Union in 2001 to that in 2004?
Keep it short and to the point. 1.04. What is the ratio of the Unemployed and educated male labor force (% of population) of Korea (Republic) in 2001 to that in 2004?
Your answer should be compact. 1.31. What is the ratio of the Unemployed and educated male labor force (% of population) in Nicaragua in 2001 to that in 2004?
Keep it short and to the point. 2.12. What is the ratio of the Unemployed and educated male labor force (% of population) of Europe(developing only) in 2001 to that in 2005?
Ensure brevity in your answer.  0.9. What is the ratio of the Unemployed and educated male labor force (% of population) in European Union in 2001 to that in 2005?
Give a very brief answer. 1.04. What is the ratio of the Unemployed and educated male labor force (% of population) of Korea (Republic) in 2001 to that in 2005?
Ensure brevity in your answer.  1.24. What is the ratio of the Unemployed and educated male labor force (% of population) of Nicaragua in 2001 to that in 2005?
Offer a terse response. 1.92. What is the ratio of the Unemployed and educated male labor force (% of population) in Europe(developing only) in 2001 to that in 2006?
Your response must be concise. 0.95. What is the ratio of the Unemployed and educated male labor force (% of population) in European Union in 2001 to that in 2006?
Give a very brief answer. 1.02. What is the ratio of the Unemployed and educated male labor force (% of population) in Korea (Republic) in 2001 to that in 2006?
Provide a short and direct response. 1.33. What is the ratio of the Unemployed and educated male labor force (% of population) in Nicaragua in 2001 to that in 2006?
Your answer should be very brief. 1.85. What is the ratio of the Unemployed and educated male labor force (% of population) of Europe(developing only) in 2002 to that in 2003?
Make the answer very short. 1.01. What is the ratio of the Unemployed and educated male labor force (% of population) in European Union in 2002 to that in 2003?
Provide a succinct answer. 1.02. What is the ratio of the Unemployed and educated male labor force (% of population) in Korea (Republic) in 2002 to that in 2003?
Provide a short and direct response. 1.22. What is the ratio of the Unemployed and educated male labor force (% of population) in Nicaragua in 2002 to that in 2003?
Keep it short and to the point. 1.52. What is the ratio of the Unemployed and educated male labor force (% of population) of Europe(developing only) in 2002 to that in 2004?
Give a very brief answer. 0.95. What is the ratio of the Unemployed and educated male labor force (% of population) in European Union in 2002 to that in 2004?
Give a very brief answer. 1.03. What is the ratio of the Unemployed and educated male labor force (% of population) in Korea (Republic) in 2002 to that in 2004?
Your answer should be very brief. 1.11. What is the ratio of the Unemployed and educated male labor force (% of population) of Nicaragua in 2002 to that in 2004?
Your answer should be very brief. 1.89. What is the ratio of the Unemployed and educated male labor force (% of population) in Europe(developing only) in 2002 to that in 2005?
Make the answer very short. 0.94. What is the ratio of the Unemployed and educated male labor force (% of population) in European Union in 2002 to that in 2005?
Provide a short and direct response. 1.03. What is the ratio of the Unemployed and educated male labor force (% of population) in Korea (Republic) in 2002 to that in 2005?
Offer a very short reply. 1.06. What is the ratio of the Unemployed and educated male labor force (% of population) in Nicaragua in 2002 to that in 2005?
Offer a very short reply. 1.71. What is the ratio of the Unemployed and educated male labor force (% of population) of European Union in 2002 to that in 2006?
Ensure brevity in your answer.  1.01. What is the ratio of the Unemployed and educated male labor force (% of population) in Korea (Republic) in 2002 to that in 2006?
Offer a terse response. 1.13. What is the ratio of the Unemployed and educated male labor force (% of population) in Nicaragua in 2002 to that in 2006?
Keep it short and to the point. 1.66. What is the ratio of the Unemployed and educated male labor force (% of population) of Europe(developing only) in 2003 to that in 2004?
Your answer should be very brief. 0.94. What is the ratio of the Unemployed and educated male labor force (% of population) in European Union in 2003 to that in 2004?
Your answer should be very brief. 1.01. What is the ratio of the Unemployed and educated male labor force (% of population) in Korea (Republic) in 2003 to that in 2004?
Offer a terse response. 0.91. What is the ratio of the Unemployed and educated male labor force (% of population) of Nicaragua in 2003 to that in 2004?
Your answer should be very brief. 1.25. What is the ratio of the Unemployed and educated male labor force (% of population) of Europe(developing only) in 2003 to that in 2005?
Your response must be concise. 0.93. What is the ratio of the Unemployed and educated male labor force (% of population) of European Union in 2003 to that in 2005?
Ensure brevity in your answer.  1.01. What is the ratio of the Unemployed and educated male labor force (% of population) in Korea (Republic) in 2003 to that in 2005?
Your answer should be compact. 0.87. What is the ratio of the Unemployed and educated male labor force (% of population) of Nicaragua in 2003 to that in 2005?
Your answer should be compact. 1.13. What is the ratio of the Unemployed and educated male labor force (% of population) in Europe(developing only) in 2003 to that in 2006?
Provide a short and direct response. 0.98. What is the ratio of the Unemployed and educated male labor force (% of population) of Korea (Republic) in 2003 to that in 2006?
Offer a very short reply. 0.93. What is the ratio of the Unemployed and educated male labor force (% of population) of Nicaragua in 2003 to that in 2006?
Your response must be concise. 1.09. What is the ratio of the Unemployed and educated male labor force (% of population) of Europe(developing only) in 2004 to that in 2005?
Give a very brief answer. 0.99. What is the ratio of the Unemployed and educated male labor force (% of population) of European Union in 2004 to that in 2005?
Your response must be concise. 1. What is the ratio of the Unemployed and educated male labor force (% of population) in Korea (Republic) in 2004 to that in 2005?
Keep it short and to the point. 0.95. What is the ratio of the Unemployed and educated male labor force (% of population) in Nicaragua in 2004 to that in 2005?
Give a very brief answer. 0.9. What is the ratio of the Unemployed and educated male labor force (% of population) in Europe(developing only) in 2004 to that in 2006?
Make the answer very short. 1.05. What is the ratio of the Unemployed and educated male labor force (% of population) of European Union in 2004 to that in 2006?
Keep it short and to the point. 0.98. What is the ratio of the Unemployed and educated male labor force (% of population) of Korea (Republic) in 2004 to that in 2006?
Your answer should be very brief. 1.02. What is the ratio of the Unemployed and educated male labor force (% of population) of Europe(developing only) in 2005 to that in 2006?
Give a very brief answer. 1.06. What is the ratio of the Unemployed and educated male labor force (% of population) in European Union in 2005 to that in 2006?
Give a very brief answer. 0.98. What is the ratio of the Unemployed and educated male labor force (% of population) of Korea (Republic) in 2005 to that in 2006?
Offer a terse response. 1.07. What is the ratio of the Unemployed and educated male labor force (% of population) in Nicaragua in 2005 to that in 2006?
Your answer should be very brief. 0.97. What is the difference between the highest and the second highest Unemployed and educated male labor force (% of population) of Europe(developing only)?
Offer a terse response. 0.47. What is the difference between the highest and the second highest Unemployed and educated male labor force (% of population) in European Union?
Ensure brevity in your answer.  2.55. What is the difference between the highest and the second highest Unemployed and educated male labor force (% of population) of Korea (Republic)?
Offer a terse response. 1.6. What is the difference between the highest and the second highest Unemployed and educated male labor force (% of population) of Nicaragua?
Offer a very short reply. 4.5. What is the difference between the highest and the lowest Unemployed and educated male labor force (% of population) in Europe(developing only)?
Make the answer very short. 10.64. What is the difference between the highest and the lowest Unemployed and educated male labor force (% of population) in European Union?
Offer a very short reply. 3.95. What is the difference between the highest and the lowest Unemployed and educated male labor force (% of population) in Korea (Republic)?
Keep it short and to the point. 8.4. What is the difference between the highest and the lowest Unemployed and educated male labor force (% of population) of Nicaragua?
Ensure brevity in your answer.  32.9. 